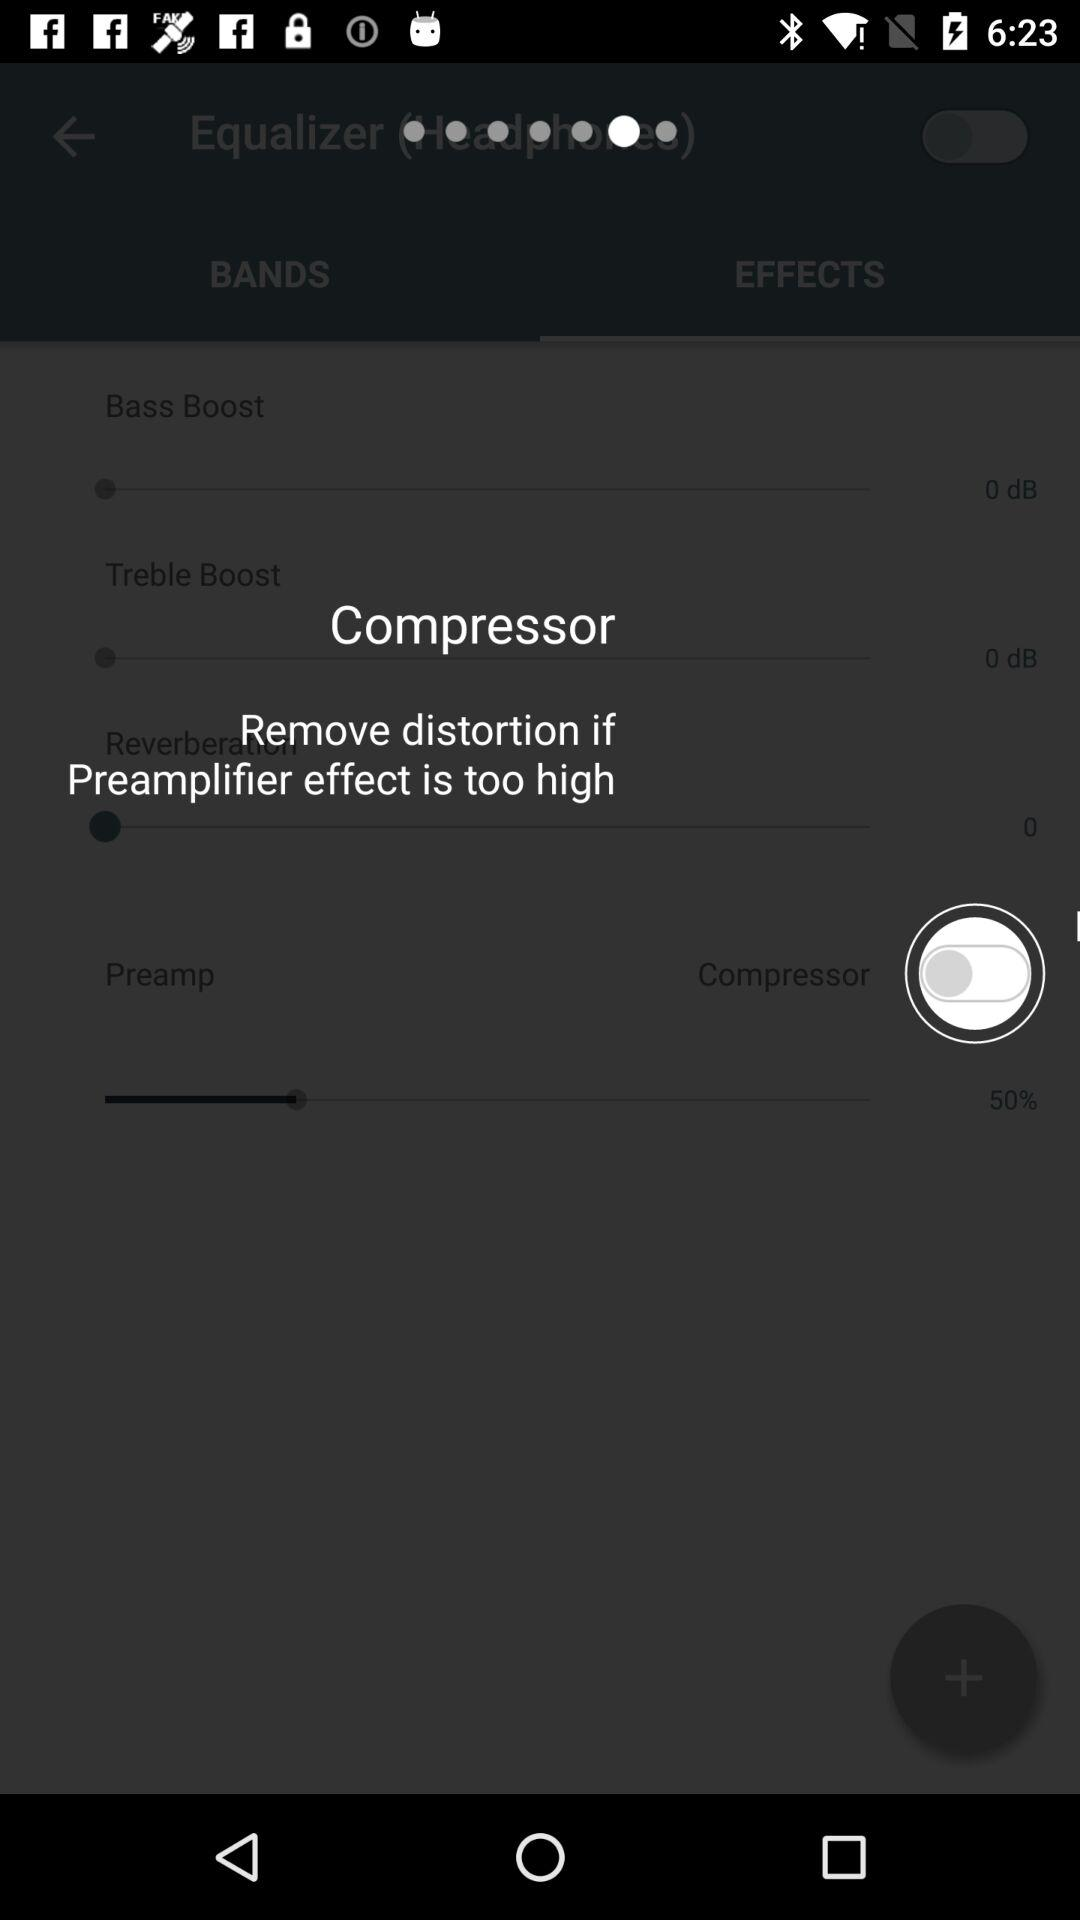How many effects are there?
Answer the question using a single word or phrase. 4 